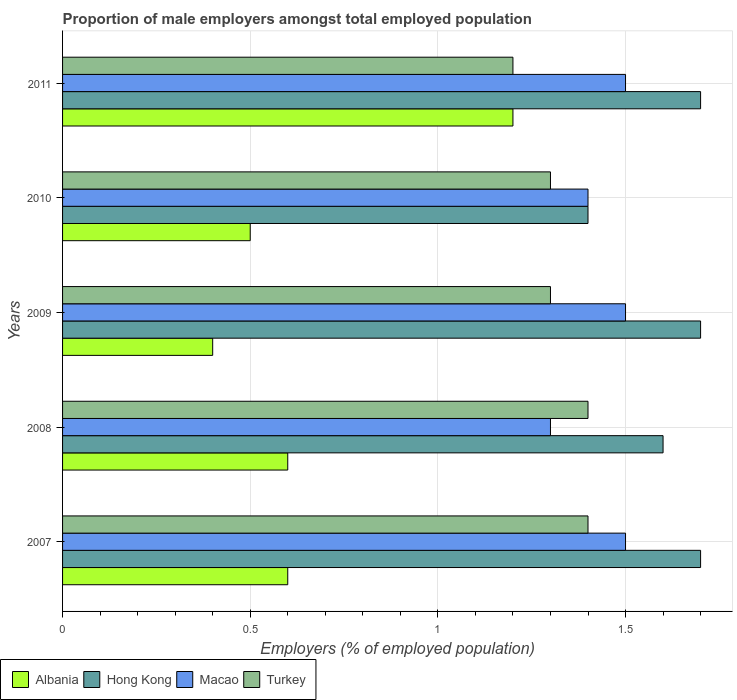How many different coloured bars are there?
Provide a short and direct response. 4. How many groups of bars are there?
Keep it short and to the point. 5. Are the number of bars per tick equal to the number of legend labels?
Your answer should be compact. Yes. What is the label of the 3rd group of bars from the top?
Keep it short and to the point. 2009. In how many cases, is the number of bars for a given year not equal to the number of legend labels?
Provide a short and direct response. 0. What is the proportion of male employers in Hong Kong in 2007?
Your answer should be very brief. 1.7. Across all years, what is the maximum proportion of male employers in Albania?
Your response must be concise. 1.2. Across all years, what is the minimum proportion of male employers in Turkey?
Your answer should be compact. 1.2. In which year was the proportion of male employers in Turkey minimum?
Ensure brevity in your answer.  2011. What is the total proportion of male employers in Albania in the graph?
Keep it short and to the point. 3.3. What is the difference between the proportion of male employers in Hong Kong in 2008 and that in 2010?
Make the answer very short. 0.2. What is the difference between the proportion of male employers in Turkey in 2010 and the proportion of male employers in Macao in 2007?
Provide a short and direct response. -0.2. What is the average proportion of male employers in Macao per year?
Give a very brief answer. 1.44. In the year 2008, what is the difference between the proportion of male employers in Macao and proportion of male employers in Hong Kong?
Give a very brief answer. -0.3. What is the ratio of the proportion of male employers in Hong Kong in 2009 to that in 2010?
Offer a terse response. 1.21. Is the proportion of male employers in Albania in 2009 less than that in 2010?
Your answer should be very brief. Yes. What is the difference between the highest and the second highest proportion of male employers in Albania?
Give a very brief answer. 0.6. What is the difference between the highest and the lowest proportion of male employers in Macao?
Your answer should be very brief. 0.2. In how many years, is the proportion of male employers in Turkey greater than the average proportion of male employers in Turkey taken over all years?
Make the answer very short. 2. Is the sum of the proportion of male employers in Albania in 2007 and 2011 greater than the maximum proportion of male employers in Macao across all years?
Keep it short and to the point. Yes. What does the 2nd bar from the top in 2009 represents?
Your response must be concise. Macao. What does the 2nd bar from the bottom in 2009 represents?
Make the answer very short. Hong Kong. Is it the case that in every year, the sum of the proportion of male employers in Turkey and proportion of male employers in Albania is greater than the proportion of male employers in Macao?
Provide a short and direct response. Yes. Are all the bars in the graph horizontal?
Keep it short and to the point. Yes. How many years are there in the graph?
Give a very brief answer. 5. What is the difference between two consecutive major ticks on the X-axis?
Keep it short and to the point. 0.5. Are the values on the major ticks of X-axis written in scientific E-notation?
Your answer should be compact. No. Does the graph contain grids?
Offer a very short reply. Yes. Where does the legend appear in the graph?
Your answer should be very brief. Bottom left. How many legend labels are there?
Offer a terse response. 4. How are the legend labels stacked?
Offer a very short reply. Horizontal. What is the title of the graph?
Offer a terse response. Proportion of male employers amongst total employed population. What is the label or title of the X-axis?
Ensure brevity in your answer.  Employers (% of employed population). What is the Employers (% of employed population) in Albania in 2007?
Make the answer very short. 0.6. What is the Employers (% of employed population) in Hong Kong in 2007?
Keep it short and to the point. 1.7. What is the Employers (% of employed population) in Macao in 2007?
Make the answer very short. 1.5. What is the Employers (% of employed population) in Turkey in 2007?
Provide a short and direct response. 1.4. What is the Employers (% of employed population) of Albania in 2008?
Offer a terse response. 0.6. What is the Employers (% of employed population) in Hong Kong in 2008?
Your response must be concise. 1.6. What is the Employers (% of employed population) in Macao in 2008?
Offer a terse response. 1.3. What is the Employers (% of employed population) of Turkey in 2008?
Your response must be concise. 1.4. What is the Employers (% of employed population) in Albania in 2009?
Give a very brief answer. 0.4. What is the Employers (% of employed population) in Hong Kong in 2009?
Your response must be concise. 1.7. What is the Employers (% of employed population) of Macao in 2009?
Give a very brief answer. 1.5. What is the Employers (% of employed population) in Turkey in 2009?
Provide a short and direct response. 1.3. What is the Employers (% of employed population) in Hong Kong in 2010?
Provide a short and direct response. 1.4. What is the Employers (% of employed population) of Macao in 2010?
Ensure brevity in your answer.  1.4. What is the Employers (% of employed population) in Turkey in 2010?
Your answer should be very brief. 1.3. What is the Employers (% of employed population) in Albania in 2011?
Offer a very short reply. 1.2. What is the Employers (% of employed population) in Hong Kong in 2011?
Provide a succinct answer. 1.7. What is the Employers (% of employed population) in Turkey in 2011?
Keep it short and to the point. 1.2. Across all years, what is the maximum Employers (% of employed population) in Albania?
Your answer should be compact. 1.2. Across all years, what is the maximum Employers (% of employed population) of Hong Kong?
Your answer should be compact. 1.7. Across all years, what is the maximum Employers (% of employed population) in Macao?
Offer a very short reply. 1.5. Across all years, what is the maximum Employers (% of employed population) in Turkey?
Give a very brief answer. 1.4. Across all years, what is the minimum Employers (% of employed population) in Albania?
Provide a succinct answer. 0.4. Across all years, what is the minimum Employers (% of employed population) in Hong Kong?
Your response must be concise. 1.4. Across all years, what is the minimum Employers (% of employed population) in Macao?
Give a very brief answer. 1.3. Across all years, what is the minimum Employers (% of employed population) of Turkey?
Offer a terse response. 1.2. What is the total Employers (% of employed population) of Turkey in the graph?
Provide a succinct answer. 6.6. What is the difference between the Employers (% of employed population) in Hong Kong in 2007 and that in 2008?
Offer a very short reply. 0.1. What is the difference between the Employers (% of employed population) in Macao in 2007 and that in 2008?
Your answer should be very brief. 0.2. What is the difference between the Employers (% of employed population) in Turkey in 2007 and that in 2008?
Provide a succinct answer. 0. What is the difference between the Employers (% of employed population) of Albania in 2007 and that in 2009?
Keep it short and to the point. 0.2. What is the difference between the Employers (% of employed population) in Hong Kong in 2007 and that in 2009?
Provide a succinct answer. 0. What is the difference between the Employers (% of employed population) of Macao in 2007 and that in 2009?
Your answer should be very brief. 0. What is the difference between the Employers (% of employed population) of Albania in 2007 and that in 2010?
Offer a very short reply. 0.1. What is the difference between the Employers (% of employed population) of Hong Kong in 2007 and that in 2010?
Provide a succinct answer. 0.3. What is the difference between the Employers (% of employed population) in Macao in 2007 and that in 2010?
Provide a succinct answer. 0.1. What is the difference between the Employers (% of employed population) in Turkey in 2007 and that in 2010?
Your answer should be very brief. 0.1. What is the difference between the Employers (% of employed population) in Albania in 2007 and that in 2011?
Make the answer very short. -0.6. What is the difference between the Employers (% of employed population) of Hong Kong in 2007 and that in 2011?
Provide a short and direct response. 0. What is the difference between the Employers (% of employed population) in Hong Kong in 2008 and that in 2009?
Ensure brevity in your answer.  -0.1. What is the difference between the Employers (% of employed population) of Turkey in 2008 and that in 2009?
Keep it short and to the point. 0.1. What is the difference between the Employers (% of employed population) of Albania in 2008 and that in 2010?
Make the answer very short. 0.1. What is the difference between the Employers (% of employed population) of Macao in 2008 and that in 2010?
Provide a succinct answer. -0.1. What is the difference between the Employers (% of employed population) of Albania in 2008 and that in 2011?
Make the answer very short. -0.6. What is the difference between the Employers (% of employed population) of Hong Kong in 2008 and that in 2011?
Provide a succinct answer. -0.1. What is the difference between the Employers (% of employed population) in Albania in 2009 and that in 2010?
Your answer should be compact. -0.1. What is the difference between the Employers (% of employed population) in Hong Kong in 2009 and that in 2010?
Offer a terse response. 0.3. What is the difference between the Employers (% of employed population) of Macao in 2009 and that in 2010?
Give a very brief answer. 0.1. What is the difference between the Employers (% of employed population) of Turkey in 2009 and that in 2010?
Make the answer very short. 0. What is the difference between the Employers (% of employed population) in Hong Kong in 2009 and that in 2011?
Ensure brevity in your answer.  0. What is the difference between the Employers (% of employed population) of Macao in 2009 and that in 2011?
Provide a succinct answer. 0. What is the difference between the Employers (% of employed population) in Turkey in 2009 and that in 2011?
Your answer should be very brief. 0.1. What is the difference between the Employers (% of employed population) of Hong Kong in 2010 and that in 2011?
Offer a very short reply. -0.3. What is the difference between the Employers (% of employed population) of Albania in 2007 and the Employers (% of employed population) of Macao in 2008?
Make the answer very short. -0.7. What is the difference between the Employers (% of employed population) of Hong Kong in 2007 and the Employers (% of employed population) of Macao in 2008?
Provide a short and direct response. 0.4. What is the difference between the Employers (% of employed population) of Hong Kong in 2007 and the Employers (% of employed population) of Turkey in 2008?
Your answer should be very brief. 0.3. What is the difference between the Employers (% of employed population) in Albania in 2007 and the Employers (% of employed population) in Hong Kong in 2009?
Ensure brevity in your answer.  -1.1. What is the difference between the Employers (% of employed population) in Albania in 2007 and the Employers (% of employed population) in Macao in 2009?
Give a very brief answer. -0.9. What is the difference between the Employers (% of employed population) of Macao in 2007 and the Employers (% of employed population) of Turkey in 2009?
Ensure brevity in your answer.  0.2. What is the difference between the Employers (% of employed population) of Albania in 2007 and the Employers (% of employed population) of Macao in 2010?
Make the answer very short. -0.8. What is the difference between the Employers (% of employed population) of Hong Kong in 2007 and the Employers (% of employed population) of Macao in 2010?
Provide a short and direct response. 0.3. What is the difference between the Employers (% of employed population) in Macao in 2007 and the Employers (% of employed population) in Turkey in 2010?
Your response must be concise. 0.2. What is the difference between the Employers (% of employed population) of Albania in 2007 and the Employers (% of employed population) of Hong Kong in 2011?
Your answer should be very brief. -1.1. What is the difference between the Employers (% of employed population) in Albania in 2007 and the Employers (% of employed population) in Turkey in 2011?
Ensure brevity in your answer.  -0.6. What is the difference between the Employers (% of employed population) of Hong Kong in 2007 and the Employers (% of employed population) of Macao in 2011?
Offer a terse response. 0.2. What is the difference between the Employers (% of employed population) in Hong Kong in 2007 and the Employers (% of employed population) in Turkey in 2011?
Provide a succinct answer. 0.5. What is the difference between the Employers (% of employed population) in Albania in 2008 and the Employers (% of employed population) in Hong Kong in 2009?
Your response must be concise. -1.1. What is the difference between the Employers (% of employed population) in Hong Kong in 2008 and the Employers (% of employed population) in Turkey in 2009?
Make the answer very short. 0.3. What is the difference between the Employers (% of employed population) of Albania in 2008 and the Employers (% of employed population) of Hong Kong in 2010?
Your response must be concise. -0.8. What is the difference between the Employers (% of employed population) in Albania in 2008 and the Employers (% of employed population) in Turkey in 2010?
Keep it short and to the point. -0.7. What is the difference between the Employers (% of employed population) of Hong Kong in 2008 and the Employers (% of employed population) of Macao in 2010?
Provide a short and direct response. 0.2. What is the difference between the Employers (% of employed population) of Hong Kong in 2008 and the Employers (% of employed population) of Turkey in 2010?
Keep it short and to the point. 0.3. What is the difference between the Employers (% of employed population) in Macao in 2008 and the Employers (% of employed population) in Turkey in 2010?
Your answer should be very brief. 0. What is the difference between the Employers (% of employed population) of Albania in 2008 and the Employers (% of employed population) of Hong Kong in 2011?
Provide a short and direct response. -1.1. What is the difference between the Employers (% of employed population) of Albania in 2008 and the Employers (% of employed population) of Macao in 2011?
Your response must be concise. -0.9. What is the difference between the Employers (% of employed population) of Albania in 2008 and the Employers (% of employed population) of Turkey in 2011?
Give a very brief answer. -0.6. What is the difference between the Employers (% of employed population) in Albania in 2009 and the Employers (% of employed population) in Hong Kong in 2010?
Give a very brief answer. -1. What is the difference between the Employers (% of employed population) of Albania in 2009 and the Employers (% of employed population) of Macao in 2011?
Your answer should be compact. -1.1. What is the difference between the Employers (% of employed population) of Hong Kong in 2009 and the Employers (% of employed population) of Macao in 2011?
Provide a succinct answer. 0.2. What is the difference between the Employers (% of employed population) in Hong Kong in 2009 and the Employers (% of employed population) in Turkey in 2011?
Offer a very short reply. 0.5. What is the difference between the Employers (% of employed population) of Macao in 2009 and the Employers (% of employed population) of Turkey in 2011?
Offer a terse response. 0.3. What is the difference between the Employers (% of employed population) of Albania in 2010 and the Employers (% of employed population) of Macao in 2011?
Keep it short and to the point. -1. What is the difference between the Employers (% of employed population) of Hong Kong in 2010 and the Employers (% of employed population) of Macao in 2011?
Keep it short and to the point. -0.1. What is the difference between the Employers (% of employed population) of Hong Kong in 2010 and the Employers (% of employed population) of Turkey in 2011?
Offer a very short reply. 0.2. What is the difference between the Employers (% of employed population) in Macao in 2010 and the Employers (% of employed population) in Turkey in 2011?
Ensure brevity in your answer.  0.2. What is the average Employers (% of employed population) of Albania per year?
Provide a succinct answer. 0.66. What is the average Employers (% of employed population) in Hong Kong per year?
Your answer should be very brief. 1.62. What is the average Employers (% of employed population) in Macao per year?
Give a very brief answer. 1.44. What is the average Employers (% of employed population) in Turkey per year?
Your response must be concise. 1.32. In the year 2007, what is the difference between the Employers (% of employed population) in Albania and Employers (% of employed population) in Hong Kong?
Provide a succinct answer. -1.1. In the year 2007, what is the difference between the Employers (% of employed population) in Hong Kong and Employers (% of employed population) in Macao?
Make the answer very short. 0.2. In the year 2007, what is the difference between the Employers (% of employed population) in Macao and Employers (% of employed population) in Turkey?
Offer a very short reply. 0.1. In the year 2008, what is the difference between the Employers (% of employed population) in Albania and Employers (% of employed population) in Hong Kong?
Keep it short and to the point. -1. In the year 2008, what is the difference between the Employers (% of employed population) of Albania and Employers (% of employed population) of Macao?
Your answer should be compact. -0.7. In the year 2008, what is the difference between the Employers (% of employed population) of Albania and Employers (% of employed population) of Turkey?
Offer a very short reply. -0.8. In the year 2008, what is the difference between the Employers (% of employed population) of Hong Kong and Employers (% of employed population) of Turkey?
Offer a very short reply. 0.2. In the year 2009, what is the difference between the Employers (% of employed population) of Albania and Employers (% of employed population) of Hong Kong?
Provide a short and direct response. -1.3. In the year 2009, what is the difference between the Employers (% of employed population) in Albania and Employers (% of employed population) in Turkey?
Make the answer very short. -0.9. In the year 2009, what is the difference between the Employers (% of employed population) in Hong Kong and Employers (% of employed population) in Macao?
Your response must be concise. 0.2. In the year 2009, what is the difference between the Employers (% of employed population) in Macao and Employers (% of employed population) in Turkey?
Provide a succinct answer. 0.2. In the year 2010, what is the difference between the Employers (% of employed population) of Hong Kong and Employers (% of employed population) of Macao?
Offer a very short reply. 0. In the year 2011, what is the difference between the Employers (% of employed population) of Albania and Employers (% of employed population) of Hong Kong?
Provide a succinct answer. -0.5. In the year 2011, what is the difference between the Employers (% of employed population) in Hong Kong and Employers (% of employed population) in Macao?
Keep it short and to the point. 0.2. In the year 2011, what is the difference between the Employers (% of employed population) of Hong Kong and Employers (% of employed population) of Turkey?
Offer a terse response. 0.5. What is the ratio of the Employers (% of employed population) of Albania in 2007 to that in 2008?
Provide a short and direct response. 1. What is the ratio of the Employers (% of employed population) of Hong Kong in 2007 to that in 2008?
Ensure brevity in your answer.  1.06. What is the ratio of the Employers (% of employed population) in Macao in 2007 to that in 2008?
Give a very brief answer. 1.15. What is the ratio of the Employers (% of employed population) in Macao in 2007 to that in 2009?
Provide a succinct answer. 1. What is the ratio of the Employers (% of employed population) of Turkey in 2007 to that in 2009?
Offer a very short reply. 1.08. What is the ratio of the Employers (% of employed population) in Albania in 2007 to that in 2010?
Offer a very short reply. 1.2. What is the ratio of the Employers (% of employed population) in Hong Kong in 2007 to that in 2010?
Offer a very short reply. 1.21. What is the ratio of the Employers (% of employed population) in Macao in 2007 to that in 2010?
Offer a very short reply. 1.07. What is the ratio of the Employers (% of employed population) of Albania in 2007 to that in 2011?
Offer a very short reply. 0.5. What is the ratio of the Employers (% of employed population) in Albania in 2008 to that in 2009?
Make the answer very short. 1.5. What is the ratio of the Employers (% of employed population) of Hong Kong in 2008 to that in 2009?
Make the answer very short. 0.94. What is the ratio of the Employers (% of employed population) in Macao in 2008 to that in 2009?
Give a very brief answer. 0.87. What is the ratio of the Employers (% of employed population) in Hong Kong in 2008 to that in 2010?
Keep it short and to the point. 1.14. What is the ratio of the Employers (% of employed population) in Turkey in 2008 to that in 2010?
Your answer should be very brief. 1.08. What is the ratio of the Employers (% of employed population) in Macao in 2008 to that in 2011?
Provide a short and direct response. 0.87. What is the ratio of the Employers (% of employed population) in Albania in 2009 to that in 2010?
Keep it short and to the point. 0.8. What is the ratio of the Employers (% of employed population) in Hong Kong in 2009 to that in 2010?
Ensure brevity in your answer.  1.21. What is the ratio of the Employers (% of employed population) in Macao in 2009 to that in 2010?
Your answer should be compact. 1.07. What is the ratio of the Employers (% of employed population) of Albania in 2010 to that in 2011?
Your answer should be very brief. 0.42. What is the ratio of the Employers (% of employed population) of Hong Kong in 2010 to that in 2011?
Ensure brevity in your answer.  0.82. What is the ratio of the Employers (% of employed population) of Macao in 2010 to that in 2011?
Ensure brevity in your answer.  0.93. What is the difference between the highest and the second highest Employers (% of employed population) in Hong Kong?
Offer a very short reply. 0. What is the difference between the highest and the second highest Employers (% of employed population) of Macao?
Give a very brief answer. 0. What is the difference between the highest and the lowest Employers (% of employed population) in Macao?
Your answer should be compact. 0.2. 